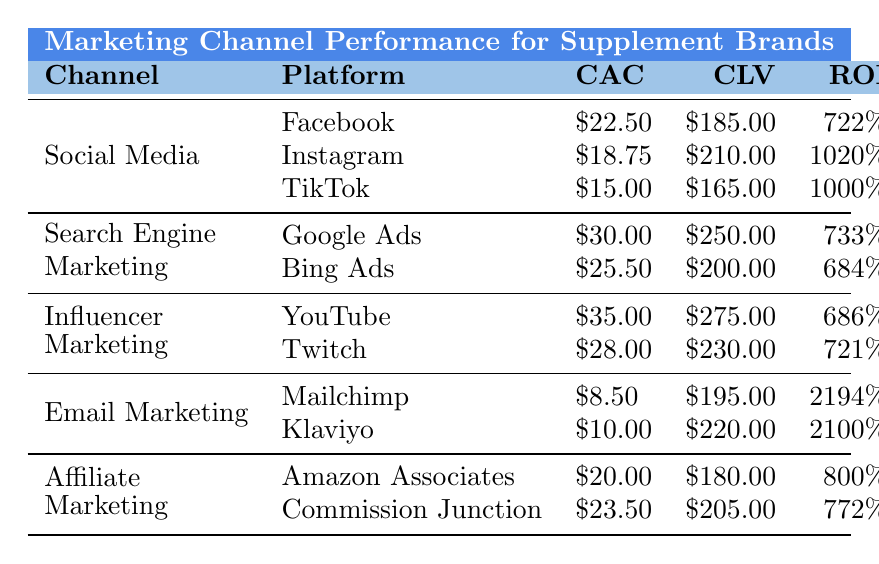What's the Customer Acquisition Cost for Instagram? The table lists Instagram under the Social Media channel and shows its Customer Acquisition Cost (CAC) as $18.75.
Answer: $18.75 Which marketing channel has the highest Customer Lifetime Value? By comparing the Customer Lifetime Values (CLV) listed, Influencer Marketing has the highest CLV from YouTube at $275.00.
Answer: YouTube under Influencer Marketing What is the ROI for Email Marketing using Mailchimp? The table indicates that the ROI for Mailchimp under Email Marketing is listed as 2194%.
Answer: 2194% What is the average Customer Acquisition Cost across all platforms? To calculate the average, sum all CAC values: ($22.50 + $18.75 + $15.00 + $30.00 + $25.50 + $35.00 + $28.00 + $8.50 + $10.00 + $20.00 + $23.50) = $ 238.75, then divide by the number of platforms (11): $238.75 / 11 = $21.79.
Answer: $21.79 Is TikTok's Customer Lifetime Value greater than that of Amazon Associates? TikTok's CLV is $165.00 while Amazon Associates' is $180.00. Since $165.00 is less than $180.00, the statement is false.
Answer: No Which platform has the lowest Customer Acquisition Cost? Upon reviewing the table, Mailchimp under Email Marketing has the lowest CAC at $8.50.
Answer: Mailchimp If I rank the platforms by ROI, which would be the second highest? The highest ROI is 2194% (Mailchimp), the next highest is 2100% (Klaviyo). So Klaviyo ranks second.
Answer: Klaviyo What is the total Customer Lifetime Value of all platforms within Social Media? Summing the CLVs in Social Media: $185.00 (Facebook) + $210.00 (Instagram) + $165.00 (TikTok) = $560.00.
Answer: $560.00 Is the ROI for Google's ads higher than that for Bing's ads? The ROI for Google Ads is 733%, and for Bing Ads, it is 684%. Since 733% is greater than 684%, the statement is true.
Answer: Yes What is the difference in Customer Lifetime Value between the highest and lowest values in Email Marketing? The highest CLV in Email Marketing is $220.00 (Klaviyo), and the lowest is $195.00 (Mailchimp). The difference is $220.00 - $195.00 = $25.00.
Answer: $25.00 